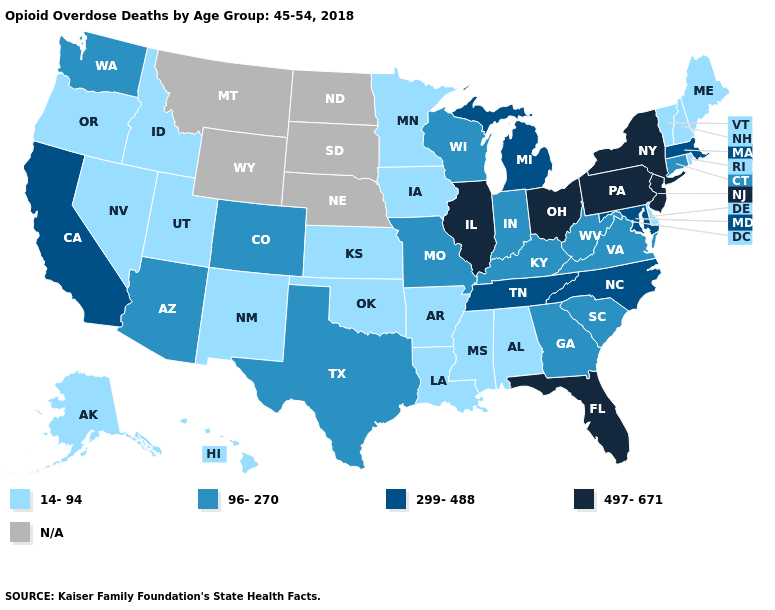Does the first symbol in the legend represent the smallest category?
Be succinct. Yes. Name the states that have a value in the range N/A?
Answer briefly. Montana, Nebraska, North Dakota, South Dakota, Wyoming. Name the states that have a value in the range 96-270?
Answer briefly. Arizona, Colorado, Connecticut, Georgia, Indiana, Kentucky, Missouri, South Carolina, Texas, Virginia, Washington, West Virginia, Wisconsin. Which states have the lowest value in the USA?
Keep it brief. Alabama, Alaska, Arkansas, Delaware, Hawaii, Idaho, Iowa, Kansas, Louisiana, Maine, Minnesota, Mississippi, Nevada, New Hampshire, New Mexico, Oklahoma, Oregon, Rhode Island, Utah, Vermont. Name the states that have a value in the range N/A?
Answer briefly. Montana, Nebraska, North Dakota, South Dakota, Wyoming. Does the map have missing data?
Write a very short answer. Yes. Among the states that border Wisconsin , which have the highest value?
Answer briefly. Illinois. Does the map have missing data?
Keep it brief. Yes. Among the states that border Connecticut , which have the highest value?
Concise answer only. New York. Does Illinois have the highest value in the USA?
Concise answer only. Yes. What is the value of Alaska?
Short answer required. 14-94. What is the lowest value in the USA?
Keep it brief. 14-94. Does Arizona have the highest value in the West?
Write a very short answer. No. What is the highest value in the USA?
Answer briefly. 497-671. 